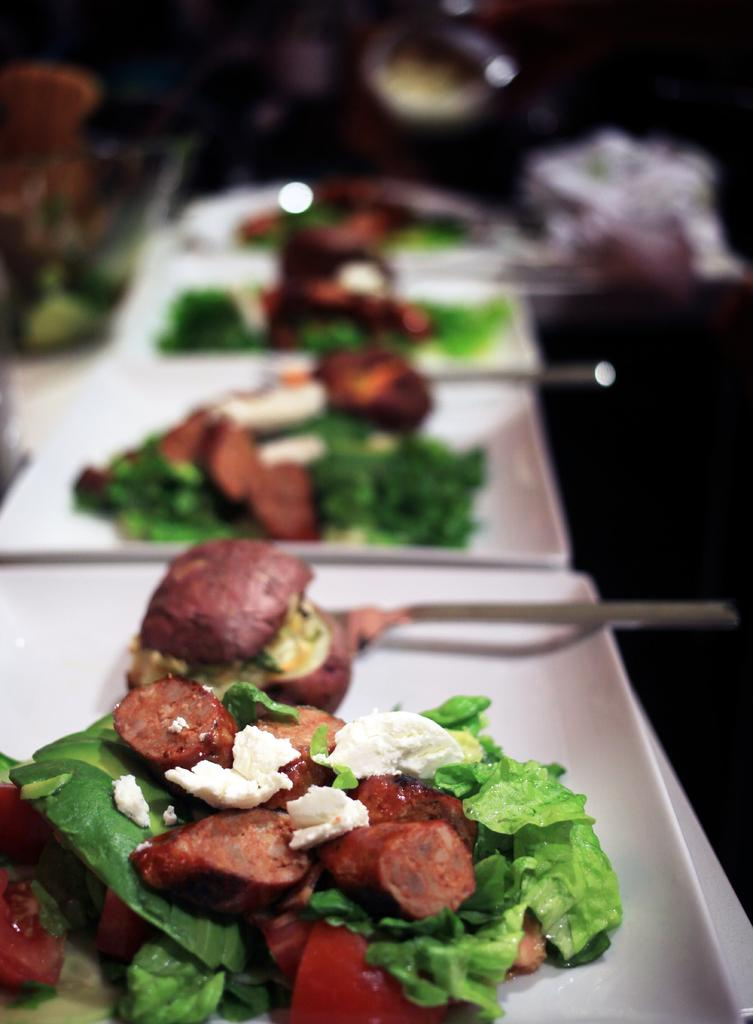What can be seen on the plates in the image? There are food items and spoons on the plates in the image. Where are the plates located? The plates are on a platform. What is the condition of the background in the image? The background of the image is blurred. Can you describe any objects visible in the background? There are some objects visible in the background. What type of fiction is the pear reading in the image? There is no pear or any indication of reading in the image. How many seats are visible in the image? There are no seats visible in the image. 